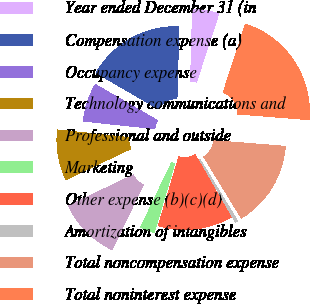<chart> <loc_0><loc_0><loc_500><loc_500><pie_chart><fcel>Year ended December 31 (in<fcel>Compensation expense (a)<fcel>Occupancy expense<fcel>Technology communications and<fcel>Professional and outside<fcel>Marketing<fcel>Other expense (b)(c)(d)<fcel>Amortization of intangibles<fcel>Total noncompensation expense<fcel>Total noninterest expense<nl><fcel>4.59%<fcel>17.08%<fcel>6.67%<fcel>8.75%<fcel>10.83%<fcel>2.51%<fcel>12.91%<fcel>0.43%<fcel>15.0%<fcel>21.24%<nl></chart> 